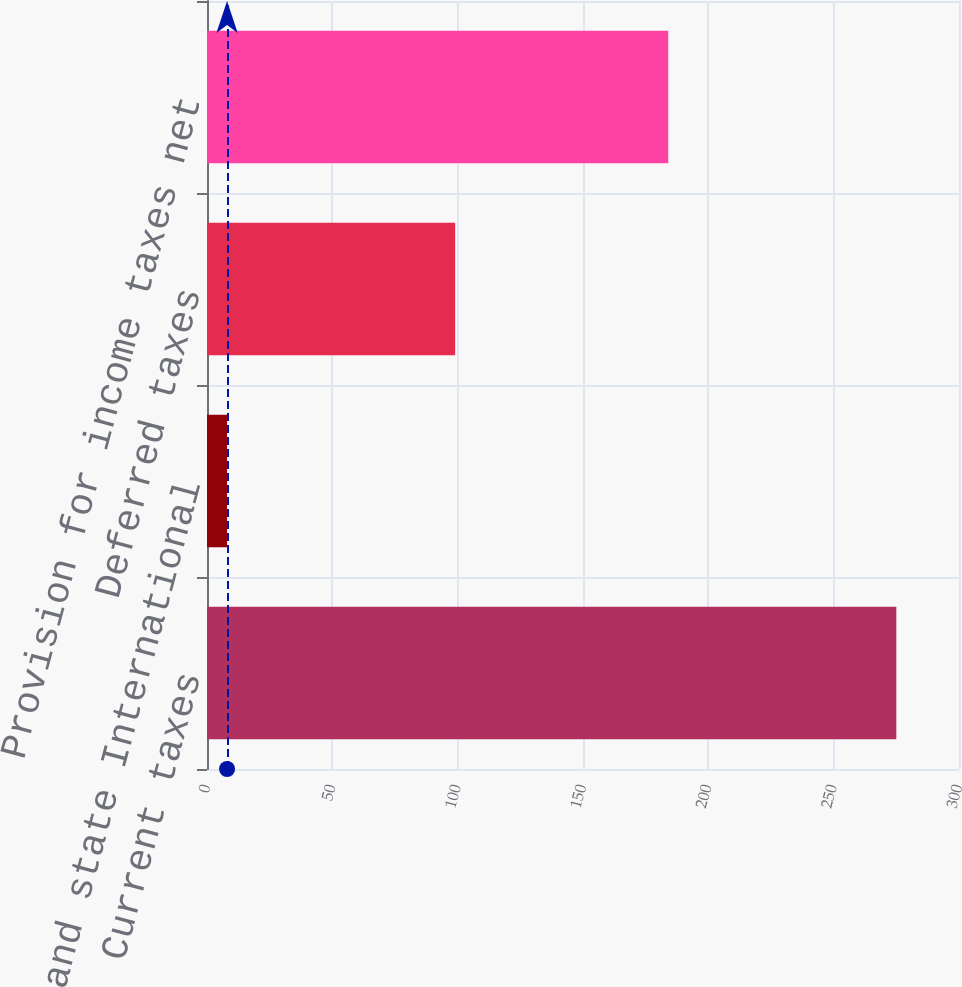Convert chart to OTSL. <chart><loc_0><loc_0><loc_500><loc_500><bar_chart><fcel>Current taxes<fcel>US and state International<fcel>Deferred taxes<fcel>Provision for income taxes net<nl><fcel>275<fcel>8<fcel>99<fcel>184<nl></chart> 